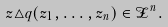Convert formula to latex. <formula><loc_0><loc_0><loc_500><loc_500>z \triangle q ( z _ { 1 } , \dots , z _ { n } ) \in \mathcal { Z } ^ { n } .</formula> 